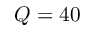Convert formula to latex. <formula><loc_0><loc_0><loc_500><loc_500>Q = 4 0</formula> 